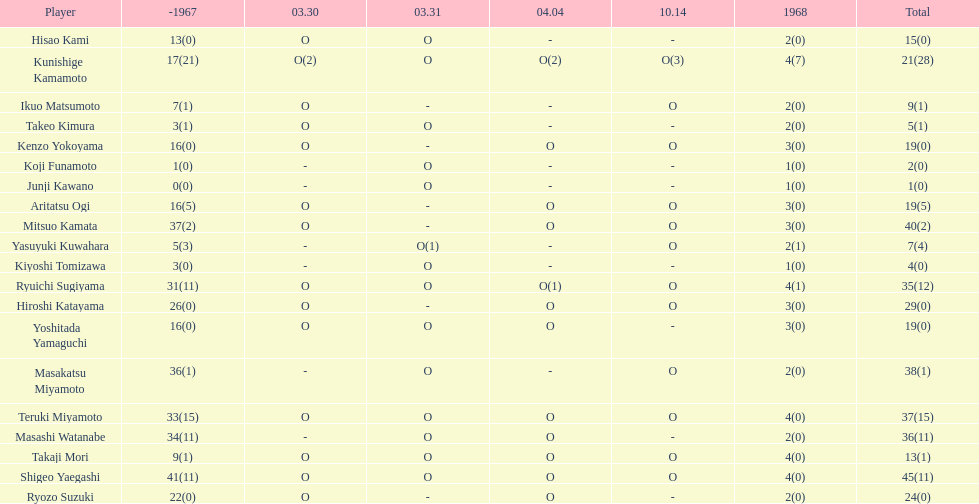How many players made an appearance that year? 20. 